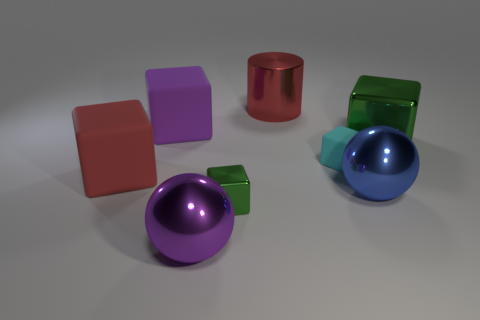The big metal thing that is both behind the blue ball and right of the small cyan rubber thing is what color?
Make the answer very short. Green. Is the green cube that is in front of the large green block made of the same material as the large green cube behind the tiny cyan matte block?
Offer a very short reply. Yes. Are there more small objects that are behind the red block than purple metal things on the right side of the big green cube?
Offer a very short reply. Yes. There is a green metal object that is the same size as the purple metallic thing; what shape is it?
Keep it short and to the point. Cube. How many objects are balls or green metal cubes that are right of the metal cylinder?
Your response must be concise. 3. Is the color of the small shiny thing the same as the large metallic block?
Keep it short and to the point. Yes. How many green objects are to the right of the blue sphere?
Ensure brevity in your answer.  1. There is a large cylinder that is made of the same material as the purple ball; what is its color?
Your answer should be very brief. Red. What number of rubber things are large gray cylinders or cyan cubes?
Your answer should be compact. 1. Are the large green block and the cyan block made of the same material?
Your answer should be very brief. No. 